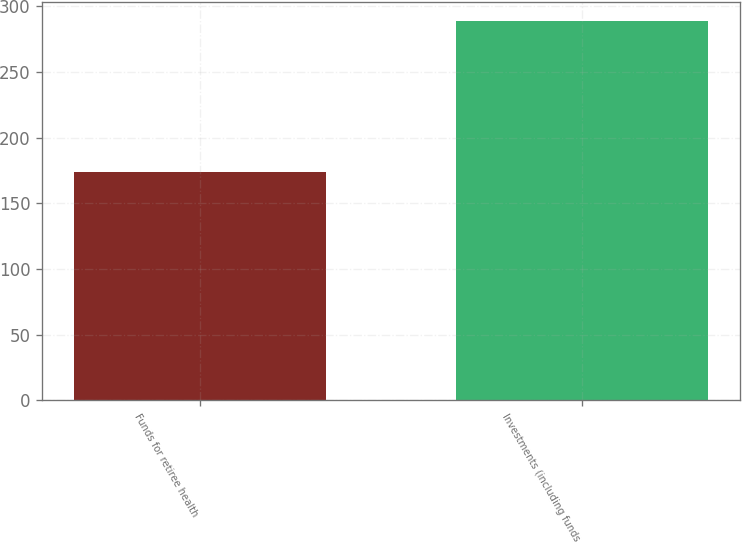Convert chart. <chart><loc_0><loc_0><loc_500><loc_500><bar_chart><fcel>Funds for retiree health<fcel>Investments (including funds<nl><fcel>174<fcel>289<nl></chart> 